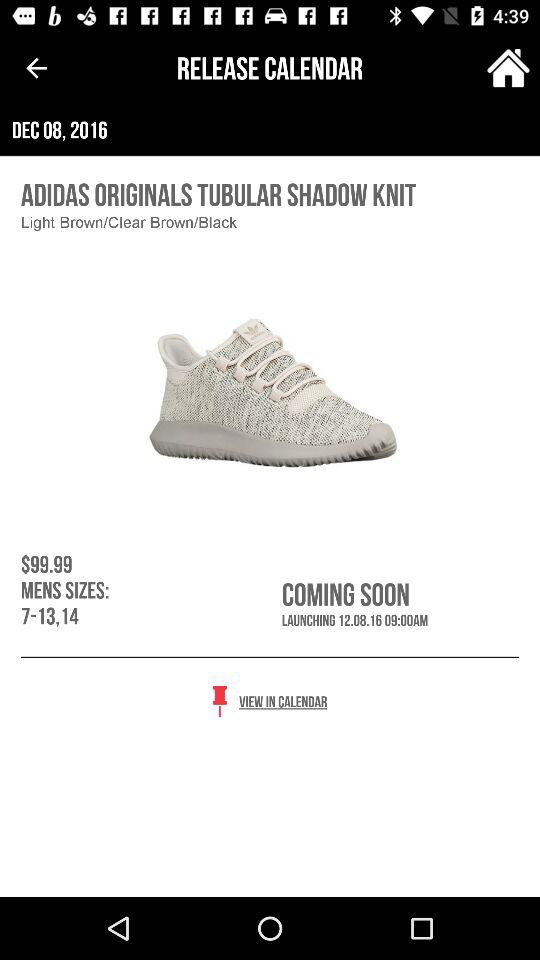At what time will these shoes be launched? These shoes will be launched on December 8, 2016 at 9 a.m. 